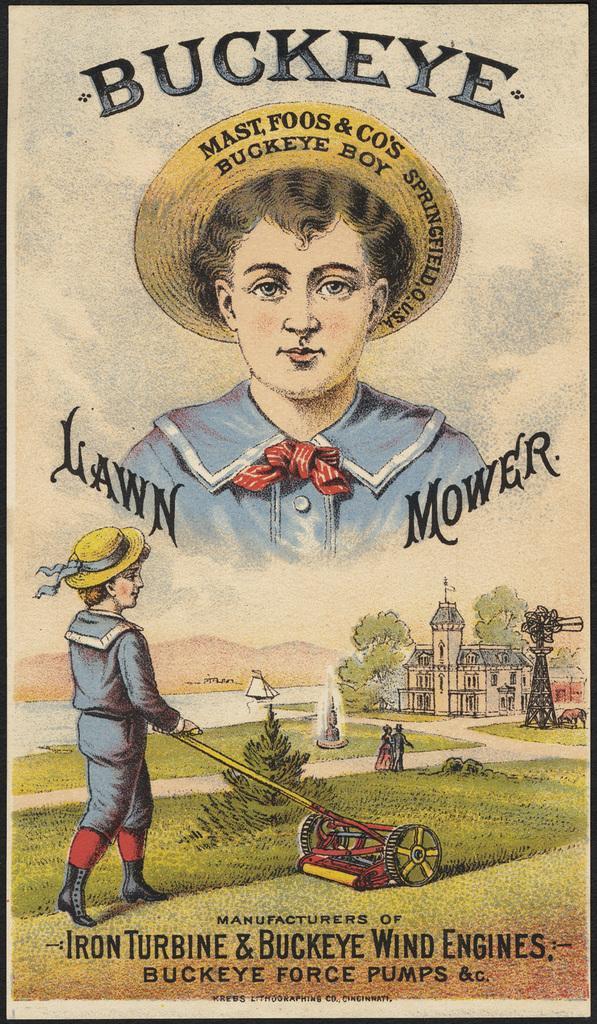Describe this image in one or two sentences. This is a paper. On the left side of the image we can see a person is walking and holding an object. In the background of the image we can see the hills, trees, building, tower, grass, animal and two persons are walking. At the bottom of the image we can see the text. At the top of the image we can see a person is wearing a hat and text. 